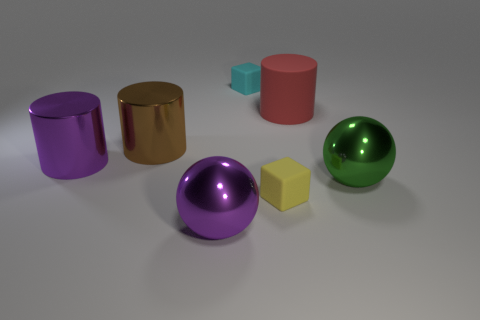How big is the red cylinder?
Your answer should be compact. Large. How many purple metallic objects are to the right of the big thing that is in front of the small block that is in front of the big brown object?
Your response must be concise. 0. There is a big purple thing that is in front of the large purple thing behind the green shiny ball; what is its shape?
Keep it short and to the point. Sphere. There is another object that is the same shape as the tiny yellow rubber object; what size is it?
Your answer should be very brief. Small. Is there any other thing that is the same size as the purple cylinder?
Your response must be concise. Yes. What is the color of the big sphere that is behind the purple ball?
Give a very brief answer. Green. What material is the large purple thing on the right side of the purple object left of the big purple metal object in front of the purple shiny cylinder?
Provide a succinct answer. Metal. There is a matte object that is in front of the metallic ball on the right side of the small cyan matte thing; what is its size?
Offer a very short reply. Small. There is another matte object that is the same shape as the tiny yellow object; what is its color?
Provide a succinct answer. Cyan. What number of big metal cylinders are the same color as the large rubber thing?
Give a very brief answer. 0. 